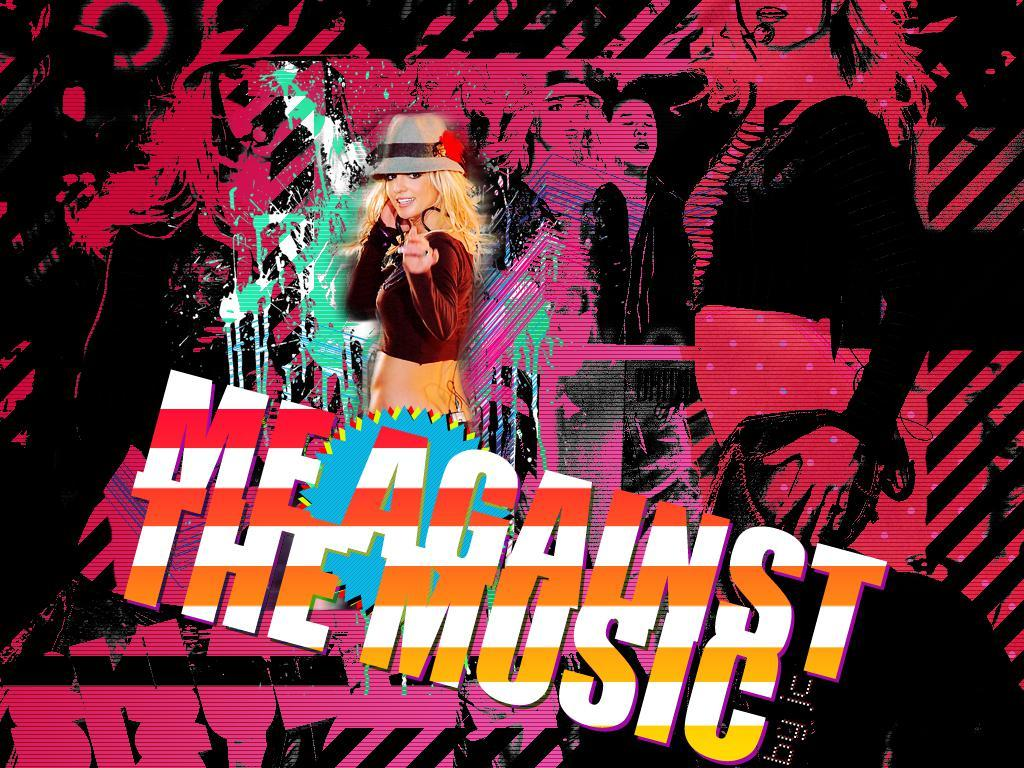What is the main subject of the poster in the image? The main subject of the poster in the image is a picture of a woman. What is the woman doing in the picture? The woman is standing in the picture. What is the woman wearing in the picture? The woman is wearing clothes and a hat in the picture. What is the woman's facial expression in the picture? The woman is smiling in the picture. What else is on the poster besides the picture of the woman? There is text on the poster. How many giants are present in the image? There are no giants present in the image; it features a picture of a woman on a poster. What type of knee support is visible in the image? There is no knee support visible in the image; it features a picture of a woman on a poster. 